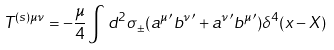Convert formula to latex. <formula><loc_0><loc_0><loc_500><loc_500>T ^ { ( s ) \mu \nu } = - \frac { \mu } { 4 } \int d ^ { 2 } \sigma _ { \pm } ( { a ^ { \mu } } ^ { \prime } { b ^ { \nu } } ^ { \prime } + { a ^ { \nu } } ^ { \prime } { b ^ { \mu } } ^ { \prime } ) \delta ^ { 4 } ( x - X )</formula> 